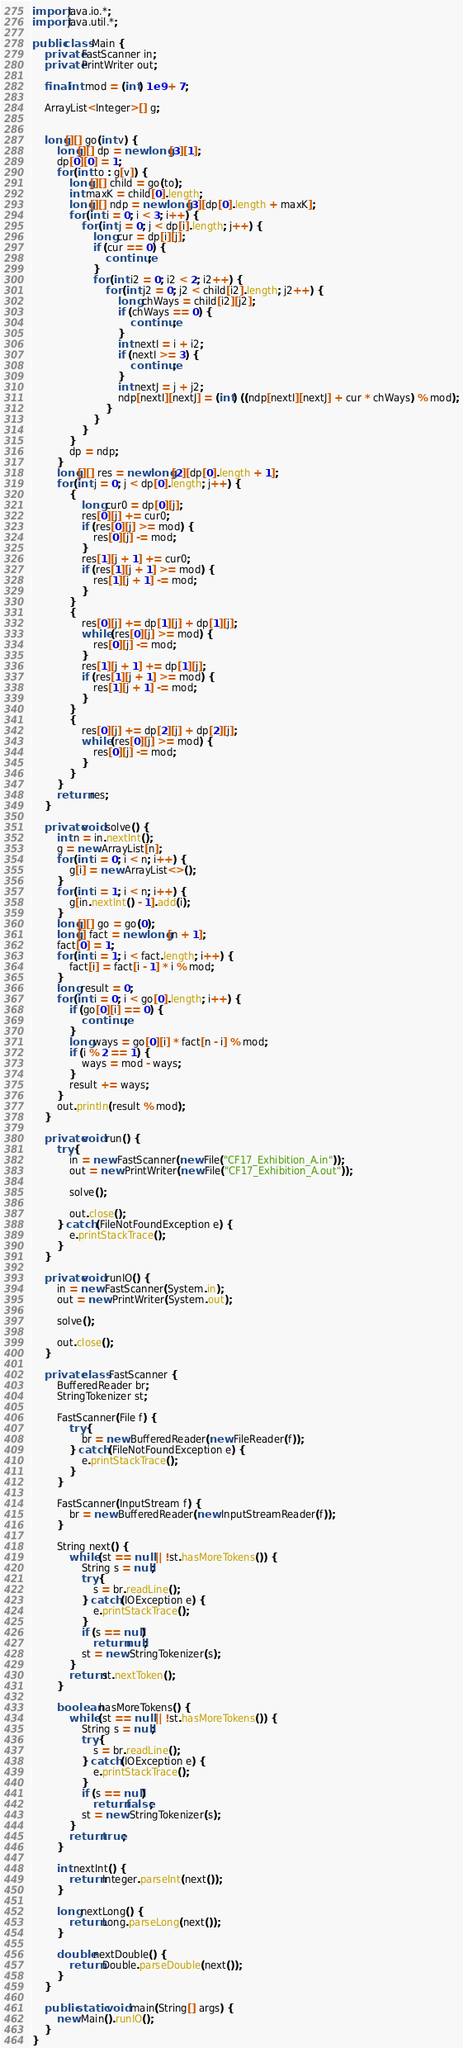<code> <loc_0><loc_0><loc_500><loc_500><_Java_>import java.io.*;
import java.util.*;

public class Main {
    private FastScanner in;
    private PrintWriter out;

    final int mod = (int) 1e9 + 7;

    ArrayList<Integer>[] g;


    long[][] go(int v) {
        long[][] dp = new long[3][1];
        dp[0][0] = 1;
        for (int to : g[v]) {
            long[][] child = go(to);
            int maxK = child[0].length;
            long[][] ndp = new long[3][dp[0].length + maxK];
            for (int i = 0; i < 3; i++) {
                for (int j = 0; j < dp[i].length; j++) {
                    long cur = dp[i][j];
                    if (cur == 0) {
                        continue;
                    }
                    for (int i2 = 0; i2 < 2; i2++) {
                        for (int j2 = 0; j2 < child[i2].length; j2++) {
                            long chWays = child[i2][j2];
                            if (chWays == 0) {
                                continue;
                            }
                            int nextI = i + i2;
                            if (nextI >= 3) {
                                continue;
                            }
                            int nextJ = j + j2;
                            ndp[nextI][nextJ] = (int) ((ndp[nextI][nextJ] + cur * chWays) % mod);
                        }
                    }
                }
            }
            dp = ndp;
        }
        long[][] res = new long[2][dp[0].length + 1];
        for (int j = 0; j < dp[0].length; j++) {
            {
                long cur0 = dp[0][j];
                res[0][j] += cur0;
                if (res[0][j] >= mod) {
                    res[0][j] -= mod;
                }
                res[1][j + 1] += cur0;
                if (res[1][j + 1] >= mod) {
                    res[1][j + 1] -= mod;
                }
            }
            {
                res[0][j] += dp[1][j] + dp[1][j];
                while (res[0][j] >= mod) {
                    res[0][j] -= mod;
                }
                res[1][j + 1] += dp[1][j];
                if (res[1][j + 1] >= mod) {
                    res[1][j + 1] -= mod;
                }
            }
            {
                res[0][j] += dp[2][j] + dp[2][j];
                while (res[0][j] >= mod) {
                    res[0][j] -= mod;
                }
            }
        }
        return res;
    }

    private void solve() {
        int n = in.nextInt();
        g = new ArrayList[n];
        for (int i = 0; i < n; i++) {
            g[i] = new ArrayList<>();
        }
        for (int i = 1; i < n; i++) {
            g[in.nextInt() - 1].add(i);
        }
        long[][] go = go(0);
        long[] fact = new long[n + 1];
        fact[0] = 1;
        for (int i = 1; i < fact.length; i++) {
            fact[i] = fact[i - 1] * i % mod;
        }
        long result = 0;
        for (int i = 0; i < go[0].length; i++) {
            if (go[0][i] == 0) {
                continue;
            }
            long ways = go[0][i] * fact[n - i] % mod;
            if (i % 2 == 1) {
                ways = mod - ways;
            }
            result += ways;
        }
        out.println(result % mod);
    }

    private void run() {
        try {
            in = new FastScanner(new File("CF17_Exhibition_A.in"));
            out = new PrintWriter(new File("CF17_Exhibition_A.out"));

            solve();

            out.close();
        } catch (FileNotFoundException e) {
            e.printStackTrace();
        }
    }

    private void runIO() {
        in = new FastScanner(System.in);
        out = new PrintWriter(System.out);

        solve();

        out.close();
    }

    private class FastScanner {
        BufferedReader br;
        StringTokenizer st;

        FastScanner(File f) {
            try {
                br = new BufferedReader(new FileReader(f));
            } catch (FileNotFoundException e) {
                e.printStackTrace();
            }
        }

        FastScanner(InputStream f) {
            br = new BufferedReader(new InputStreamReader(f));
        }

        String next() {
            while (st == null || !st.hasMoreTokens()) {
                String s = null;
                try {
                    s = br.readLine();
                } catch (IOException e) {
                    e.printStackTrace();
                }
                if (s == null)
                    return null;
                st = new StringTokenizer(s);
            }
            return st.nextToken();
        }

        boolean hasMoreTokens() {
            while (st == null || !st.hasMoreTokens()) {
                String s = null;
                try {
                    s = br.readLine();
                } catch (IOException e) {
                    e.printStackTrace();
                }
                if (s == null)
                    return false;
                st = new StringTokenizer(s);
            }
            return true;
        }

        int nextInt() {
            return Integer.parseInt(next());
        }

        long nextLong() {
            return Long.parseLong(next());
        }

        double nextDouble() {
            return Double.parseDouble(next());
        }
    }

    public static void main(String[] args) {
        new Main().runIO();
    }
}</code> 